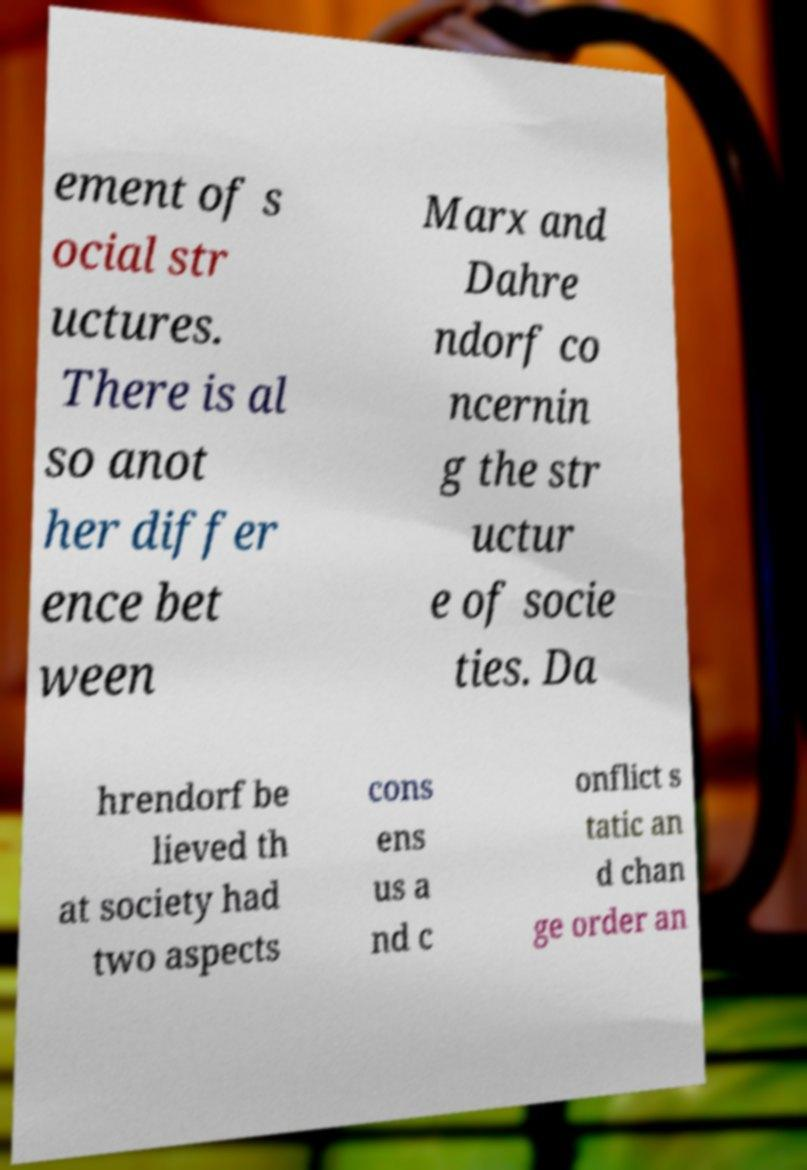Please identify and transcribe the text found in this image. ement of s ocial str uctures. There is al so anot her differ ence bet ween Marx and Dahre ndorf co ncernin g the str uctur e of socie ties. Da hrendorf be lieved th at society had two aspects cons ens us a nd c onflict s tatic an d chan ge order an 